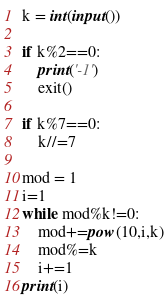<code> <loc_0><loc_0><loc_500><loc_500><_Python_>k = int(input())

if k%2==0:
    print('-1')
    exit()

if k%7==0:
    k//=7

mod = 1
i=1
while mod%k!=0:
    mod+=pow(10,i,k)
    mod%=k
    i+=1
print(i)
</code> 